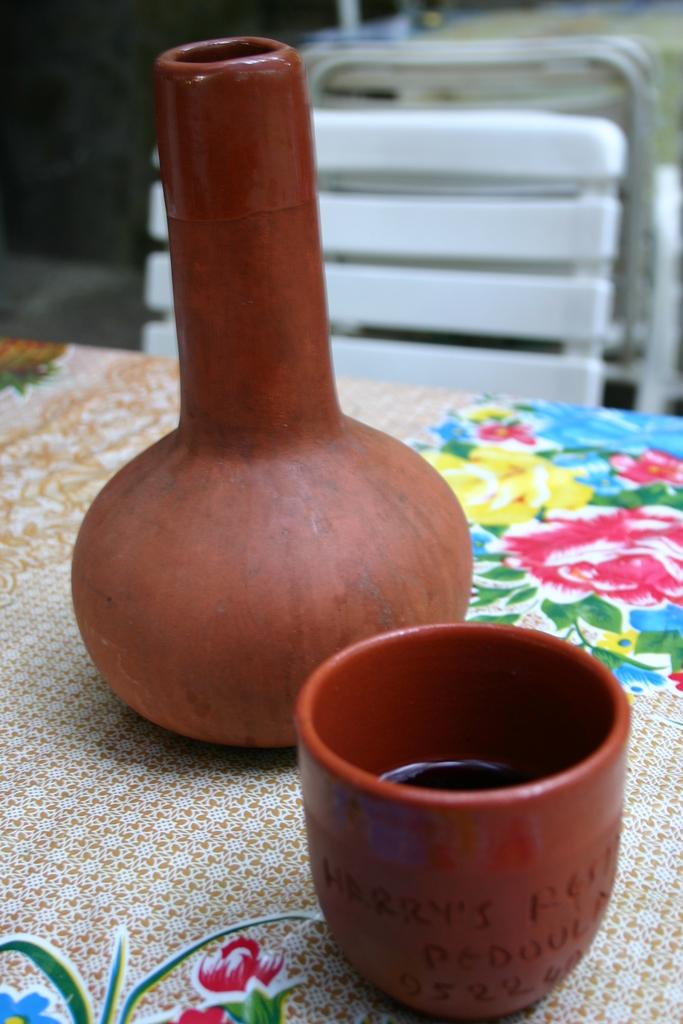What is located in the foreground of the image? There is a table in the foreground of the image. What is placed on the table? Posts are placed on the table. What can be seen in the background of the image? There are objects visible in the background of the image. What type of dirt can be seen on the leather team's uniforms in the image? There is no dirt, leather, or team present in the image. 